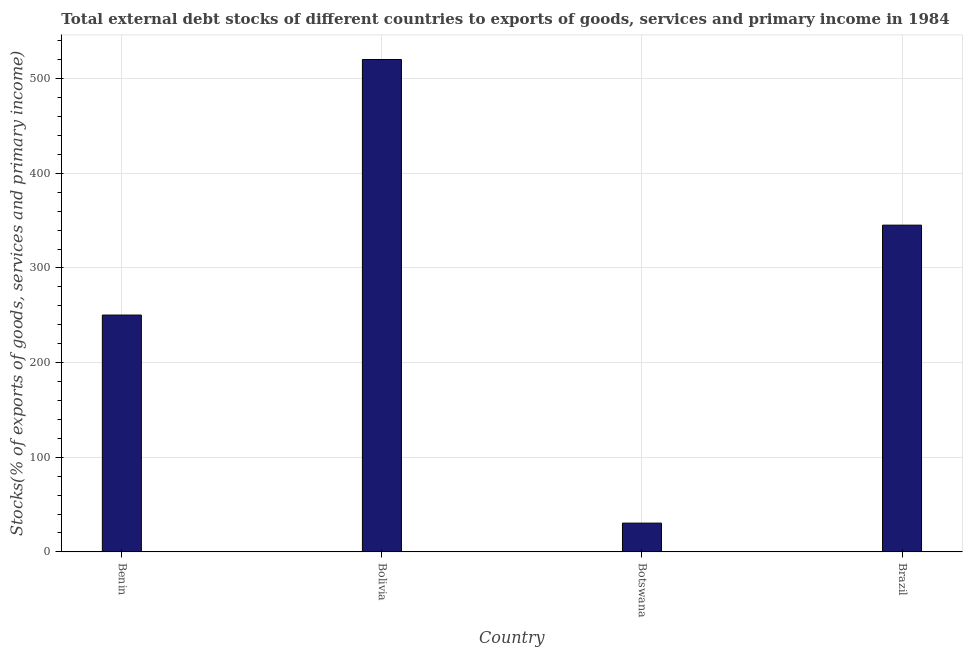What is the title of the graph?
Give a very brief answer. Total external debt stocks of different countries to exports of goods, services and primary income in 1984. What is the label or title of the Y-axis?
Offer a very short reply. Stocks(% of exports of goods, services and primary income). What is the external debt stocks in Bolivia?
Offer a very short reply. 520.31. Across all countries, what is the maximum external debt stocks?
Your response must be concise. 520.31. Across all countries, what is the minimum external debt stocks?
Provide a succinct answer. 30.42. In which country was the external debt stocks maximum?
Your answer should be very brief. Bolivia. In which country was the external debt stocks minimum?
Keep it short and to the point. Botswana. What is the sum of the external debt stocks?
Offer a very short reply. 1146.26. What is the difference between the external debt stocks in Benin and Brazil?
Your answer should be very brief. -95. What is the average external debt stocks per country?
Your answer should be compact. 286.56. What is the median external debt stocks?
Keep it short and to the point. 297.77. In how many countries, is the external debt stocks greater than 240 %?
Provide a short and direct response. 3. What is the ratio of the external debt stocks in Benin to that in Botswana?
Make the answer very short. 8.23. Is the external debt stocks in Bolivia less than that in Botswana?
Offer a terse response. No. What is the difference between the highest and the second highest external debt stocks?
Keep it short and to the point. 175.04. Is the sum of the external debt stocks in Benin and Bolivia greater than the maximum external debt stocks across all countries?
Make the answer very short. Yes. What is the difference between the highest and the lowest external debt stocks?
Offer a very short reply. 489.89. In how many countries, is the external debt stocks greater than the average external debt stocks taken over all countries?
Keep it short and to the point. 2. Are all the bars in the graph horizontal?
Ensure brevity in your answer.  No. What is the difference between two consecutive major ticks on the Y-axis?
Your answer should be very brief. 100. What is the Stocks(% of exports of goods, services and primary income) in Benin?
Your response must be concise. 250.26. What is the Stocks(% of exports of goods, services and primary income) of Bolivia?
Your answer should be very brief. 520.31. What is the Stocks(% of exports of goods, services and primary income) in Botswana?
Your answer should be compact. 30.42. What is the Stocks(% of exports of goods, services and primary income) of Brazil?
Your answer should be very brief. 345.27. What is the difference between the Stocks(% of exports of goods, services and primary income) in Benin and Bolivia?
Your answer should be very brief. -270.04. What is the difference between the Stocks(% of exports of goods, services and primary income) in Benin and Botswana?
Provide a short and direct response. 219.85. What is the difference between the Stocks(% of exports of goods, services and primary income) in Benin and Brazil?
Keep it short and to the point. -95. What is the difference between the Stocks(% of exports of goods, services and primary income) in Bolivia and Botswana?
Offer a terse response. 489.89. What is the difference between the Stocks(% of exports of goods, services and primary income) in Bolivia and Brazil?
Offer a terse response. 175.04. What is the difference between the Stocks(% of exports of goods, services and primary income) in Botswana and Brazil?
Provide a short and direct response. -314.85. What is the ratio of the Stocks(% of exports of goods, services and primary income) in Benin to that in Bolivia?
Make the answer very short. 0.48. What is the ratio of the Stocks(% of exports of goods, services and primary income) in Benin to that in Botswana?
Offer a terse response. 8.23. What is the ratio of the Stocks(% of exports of goods, services and primary income) in Benin to that in Brazil?
Offer a terse response. 0.72. What is the ratio of the Stocks(% of exports of goods, services and primary income) in Bolivia to that in Botswana?
Ensure brevity in your answer.  17.11. What is the ratio of the Stocks(% of exports of goods, services and primary income) in Bolivia to that in Brazil?
Provide a short and direct response. 1.51. What is the ratio of the Stocks(% of exports of goods, services and primary income) in Botswana to that in Brazil?
Your answer should be very brief. 0.09. 